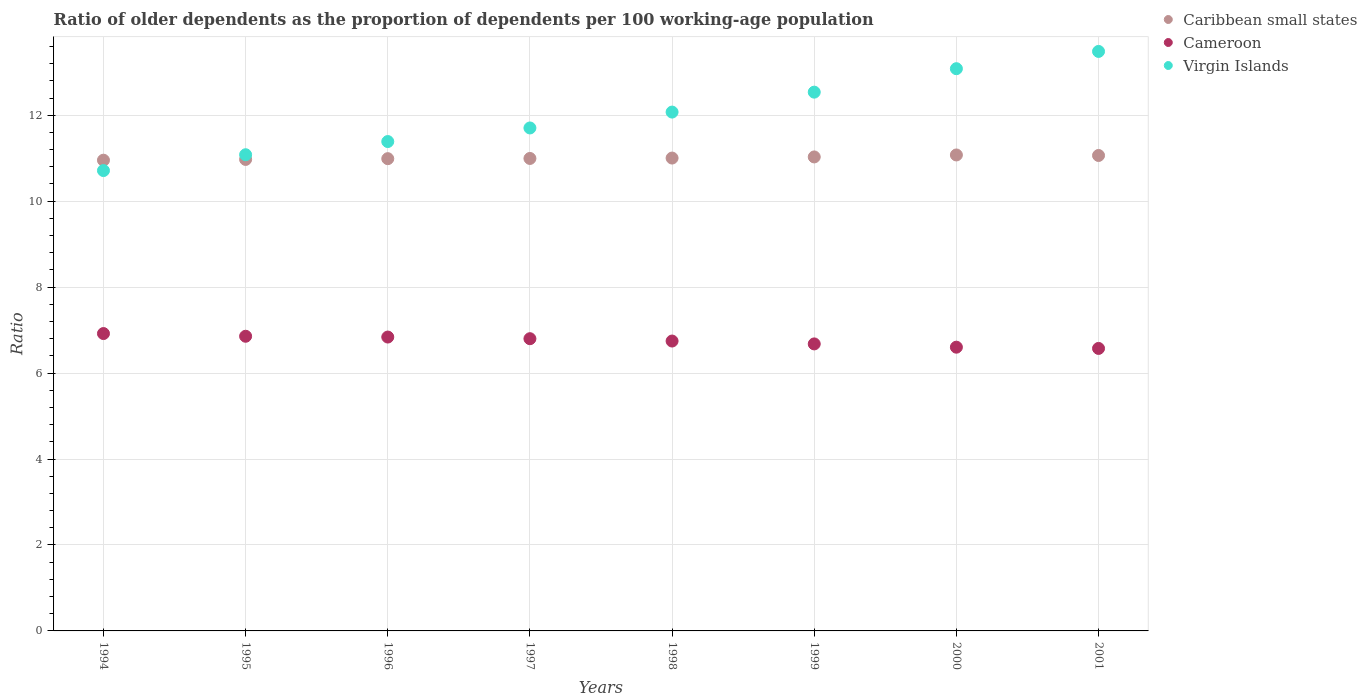What is the age dependency ratio(old) in Virgin Islands in 1995?
Your response must be concise. 11.08. Across all years, what is the maximum age dependency ratio(old) in Cameroon?
Offer a very short reply. 6.92. Across all years, what is the minimum age dependency ratio(old) in Cameroon?
Your response must be concise. 6.57. In which year was the age dependency ratio(old) in Virgin Islands minimum?
Provide a succinct answer. 1994. What is the total age dependency ratio(old) in Caribbean small states in the graph?
Your response must be concise. 88.08. What is the difference between the age dependency ratio(old) in Virgin Islands in 1997 and that in 1998?
Provide a succinct answer. -0.37. What is the difference between the age dependency ratio(old) in Caribbean small states in 1995 and the age dependency ratio(old) in Virgin Islands in 1996?
Give a very brief answer. -0.42. What is the average age dependency ratio(old) in Caribbean small states per year?
Make the answer very short. 11.01. In the year 2001, what is the difference between the age dependency ratio(old) in Caribbean small states and age dependency ratio(old) in Virgin Islands?
Your answer should be compact. -2.42. In how many years, is the age dependency ratio(old) in Virgin Islands greater than 1.6?
Provide a succinct answer. 8. What is the ratio of the age dependency ratio(old) in Cameroon in 1997 to that in 1998?
Your answer should be very brief. 1.01. Is the age dependency ratio(old) in Virgin Islands in 1995 less than that in 2001?
Keep it short and to the point. Yes. Is the difference between the age dependency ratio(old) in Caribbean small states in 1995 and 1998 greater than the difference between the age dependency ratio(old) in Virgin Islands in 1995 and 1998?
Your answer should be compact. Yes. What is the difference between the highest and the second highest age dependency ratio(old) in Virgin Islands?
Your answer should be very brief. 0.4. What is the difference between the highest and the lowest age dependency ratio(old) in Caribbean small states?
Give a very brief answer. 0.12. In how many years, is the age dependency ratio(old) in Caribbean small states greater than the average age dependency ratio(old) in Caribbean small states taken over all years?
Your response must be concise. 3. Is it the case that in every year, the sum of the age dependency ratio(old) in Caribbean small states and age dependency ratio(old) in Virgin Islands  is greater than the age dependency ratio(old) in Cameroon?
Your answer should be very brief. Yes. Is the age dependency ratio(old) in Virgin Islands strictly less than the age dependency ratio(old) in Caribbean small states over the years?
Your response must be concise. No. Are the values on the major ticks of Y-axis written in scientific E-notation?
Your answer should be compact. No. Does the graph contain any zero values?
Ensure brevity in your answer.  No. Does the graph contain grids?
Give a very brief answer. Yes. How are the legend labels stacked?
Give a very brief answer. Vertical. What is the title of the graph?
Provide a short and direct response. Ratio of older dependents as the proportion of dependents per 100 working-age population. What is the label or title of the X-axis?
Offer a very short reply. Years. What is the label or title of the Y-axis?
Keep it short and to the point. Ratio. What is the Ratio in Caribbean small states in 1994?
Make the answer very short. 10.95. What is the Ratio in Cameroon in 1994?
Your response must be concise. 6.92. What is the Ratio in Virgin Islands in 1994?
Give a very brief answer. 10.71. What is the Ratio of Caribbean small states in 1995?
Offer a terse response. 10.97. What is the Ratio in Cameroon in 1995?
Ensure brevity in your answer.  6.86. What is the Ratio of Virgin Islands in 1995?
Your response must be concise. 11.08. What is the Ratio in Caribbean small states in 1996?
Provide a succinct answer. 10.99. What is the Ratio in Cameroon in 1996?
Provide a succinct answer. 6.84. What is the Ratio of Virgin Islands in 1996?
Offer a terse response. 11.39. What is the Ratio of Caribbean small states in 1997?
Keep it short and to the point. 10.99. What is the Ratio in Cameroon in 1997?
Your answer should be very brief. 6.8. What is the Ratio in Virgin Islands in 1997?
Your answer should be compact. 11.7. What is the Ratio of Caribbean small states in 1998?
Provide a short and direct response. 11. What is the Ratio of Cameroon in 1998?
Your response must be concise. 6.75. What is the Ratio in Virgin Islands in 1998?
Your answer should be compact. 12.07. What is the Ratio of Caribbean small states in 1999?
Ensure brevity in your answer.  11.03. What is the Ratio in Cameroon in 1999?
Make the answer very short. 6.68. What is the Ratio of Virgin Islands in 1999?
Provide a succinct answer. 12.54. What is the Ratio in Caribbean small states in 2000?
Give a very brief answer. 11.08. What is the Ratio in Cameroon in 2000?
Offer a terse response. 6.6. What is the Ratio of Virgin Islands in 2000?
Your response must be concise. 13.08. What is the Ratio of Caribbean small states in 2001?
Offer a very short reply. 11.06. What is the Ratio in Cameroon in 2001?
Keep it short and to the point. 6.57. What is the Ratio of Virgin Islands in 2001?
Keep it short and to the point. 13.48. Across all years, what is the maximum Ratio of Caribbean small states?
Your response must be concise. 11.08. Across all years, what is the maximum Ratio in Cameroon?
Offer a terse response. 6.92. Across all years, what is the maximum Ratio of Virgin Islands?
Provide a succinct answer. 13.48. Across all years, what is the minimum Ratio of Caribbean small states?
Keep it short and to the point. 10.95. Across all years, what is the minimum Ratio in Cameroon?
Provide a succinct answer. 6.57. Across all years, what is the minimum Ratio in Virgin Islands?
Your answer should be compact. 10.71. What is the total Ratio of Caribbean small states in the graph?
Offer a very short reply. 88.08. What is the total Ratio in Cameroon in the graph?
Make the answer very short. 54.01. What is the total Ratio of Virgin Islands in the graph?
Keep it short and to the point. 96.06. What is the difference between the Ratio in Caribbean small states in 1994 and that in 1995?
Provide a short and direct response. -0.02. What is the difference between the Ratio in Cameroon in 1994 and that in 1995?
Provide a succinct answer. 0.06. What is the difference between the Ratio of Virgin Islands in 1994 and that in 1995?
Ensure brevity in your answer.  -0.37. What is the difference between the Ratio of Caribbean small states in 1994 and that in 1996?
Offer a very short reply. -0.04. What is the difference between the Ratio of Cameroon in 1994 and that in 1996?
Make the answer very short. 0.08. What is the difference between the Ratio in Virgin Islands in 1994 and that in 1996?
Your response must be concise. -0.68. What is the difference between the Ratio of Caribbean small states in 1994 and that in 1997?
Provide a short and direct response. -0.04. What is the difference between the Ratio in Cameroon in 1994 and that in 1997?
Offer a terse response. 0.12. What is the difference between the Ratio of Virgin Islands in 1994 and that in 1997?
Your response must be concise. -0.99. What is the difference between the Ratio of Caribbean small states in 1994 and that in 1998?
Your answer should be very brief. -0.05. What is the difference between the Ratio in Cameroon in 1994 and that in 1998?
Provide a short and direct response. 0.17. What is the difference between the Ratio in Virgin Islands in 1994 and that in 1998?
Provide a succinct answer. -1.36. What is the difference between the Ratio in Caribbean small states in 1994 and that in 1999?
Provide a succinct answer. -0.08. What is the difference between the Ratio in Cameroon in 1994 and that in 1999?
Keep it short and to the point. 0.24. What is the difference between the Ratio of Virgin Islands in 1994 and that in 1999?
Ensure brevity in your answer.  -1.82. What is the difference between the Ratio in Caribbean small states in 1994 and that in 2000?
Keep it short and to the point. -0.12. What is the difference between the Ratio in Cameroon in 1994 and that in 2000?
Your answer should be very brief. 0.32. What is the difference between the Ratio of Virgin Islands in 1994 and that in 2000?
Your answer should be very brief. -2.37. What is the difference between the Ratio of Caribbean small states in 1994 and that in 2001?
Offer a terse response. -0.11. What is the difference between the Ratio of Cameroon in 1994 and that in 2001?
Keep it short and to the point. 0.35. What is the difference between the Ratio of Virgin Islands in 1994 and that in 2001?
Ensure brevity in your answer.  -2.77. What is the difference between the Ratio of Caribbean small states in 1995 and that in 1996?
Provide a short and direct response. -0.02. What is the difference between the Ratio of Cameroon in 1995 and that in 1996?
Your response must be concise. 0.02. What is the difference between the Ratio of Virgin Islands in 1995 and that in 1996?
Your response must be concise. -0.31. What is the difference between the Ratio in Caribbean small states in 1995 and that in 1997?
Your response must be concise. -0.02. What is the difference between the Ratio of Cameroon in 1995 and that in 1997?
Your answer should be very brief. 0.06. What is the difference between the Ratio of Virgin Islands in 1995 and that in 1997?
Offer a terse response. -0.62. What is the difference between the Ratio in Caribbean small states in 1995 and that in 1998?
Make the answer very short. -0.03. What is the difference between the Ratio of Cameroon in 1995 and that in 1998?
Keep it short and to the point. 0.11. What is the difference between the Ratio of Virgin Islands in 1995 and that in 1998?
Your answer should be compact. -0.99. What is the difference between the Ratio in Caribbean small states in 1995 and that in 1999?
Your response must be concise. -0.06. What is the difference between the Ratio in Cameroon in 1995 and that in 1999?
Keep it short and to the point. 0.18. What is the difference between the Ratio of Virgin Islands in 1995 and that in 1999?
Ensure brevity in your answer.  -1.46. What is the difference between the Ratio of Caribbean small states in 1995 and that in 2000?
Provide a succinct answer. -0.1. What is the difference between the Ratio in Cameroon in 1995 and that in 2000?
Provide a succinct answer. 0.25. What is the difference between the Ratio of Virgin Islands in 1995 and that in 2000?
Offer a terse response. -2. What is the difference between the Ratio of Caribbean small states in 1995 and that in 2001?
Ensure brevity in your answer.  -0.09. What is the difference between the Ratio in Cameroon in 1995 and that in 2001?
Offer a terse response. 0.28. What is the difference between the Ratio in Virgin Islands in 1995 and that in 2001?
Offer a very short reply. -2.4. What is the difference between the Ratio in Caribbean small states in 1996 and that in 1997?
Make the answer very short. -0. What is the difference between the Ratio of Cameroon in 1996 and that in 1997?
Offer a terse response. 0.04. What is the difference between the Ratio in Virgin Islands in 1996 and that in 1997?
Provide a succinct answer. -0.32. What is the difference between the Ratio in Caribbean small states in 1996 and that in 1998?
Provide a succinct answer. -0.01. What is the difference between the Ratio in Cameroon in 1996 and that in 1998?
Your answer should be compact. 0.09. What is the difference between the Ratio of Virgin Islands in 1996 and that in 1998?
Provide a succinct answer. -0.69. What is the difference between the Ratio in Caribbean small states in 1996 and that in 1999?
Make the answer very short. -0.04. What is the difference between the Ratio of Cameroon in 1996 and that in 1999?
Your answer should be compact. 0.16. What is the difference between the Ratio of Virgin Islands in 1996 and that in 1999?
Give a very brief answer. -1.15. What is the difference between the Ratio of Caribbean small states in 1996 and that in 2000?
Make the answer very short. -0.09. What is the difference between the Ratio of Cameroon in 1996 and that in 2000?
Make the answer very short. 0.24. What is the difference between the Ratio of Virgin Islands in 1996 and that in 2000?
Offer a very short reply. -1.7. What is the difference between the Ratio of Caribbean small states in 1996 and that in 2001?
Your answer should be compact. -0.07. What is the difference between the Ratio in Cameroon in 1996 and that in 2001?
Your answer should be compact. 0.26. What is the difference between the Ratio of Virgin Islands in 1996 and that in 2001?
Give a very brief answer. -2.1. What is the difference between the Ratio in Caribbean small states in 1997 and that in 1998?
Offer a terse response. -0.01. What is the difference between the Ratio in Cameroon in 1997 and that in 1998?
Your answer should be compact. 0.05. What is the difference between the Ratio in Virgin Islands in 1997 and that in 1998?
Your response must be concise. -0.37. What is the difference between the Ratio in Caribbean small states in 1997 and that in 1999?
Provide a succinct answer. -0.04. What is the difference between the Ratio in Cameroon in 1997 and that in 1999?
Offer a terse response. 0.12. What is the difference between the Ratio of Virgin Islands in 1997 and that in 1999?
Keep it short and to the point. -0.83. What is the difference between the Ratio of Caribbean small states in 1997 and that in 2000?
Keep it short and to the point. -0.08. What is the difference between the Ratio of Cameroon in 1997 and that in 2000?
Your answer should be compact. 0.2. What is the difference between the Ratio in Virgin Islands in 1997 and that in 2000?
Make the answer very short. -1.38. What is the difference between the Ratio in Caribbean small states in 1997 and that in 2001?
Ensure brevity in your answer.  -0.07. What is the difference between the Ratio in Cameroon in 1997 and that in 2001?
Your answer should be compact. 0.23. What is the difference between the Ratio in Virgin Islands in 1997 and that in 2001?
Provide a short and direct response. -1.78. What is the difference between the Ratio in Caribbean small states in 1998 and that in 1999?
Ensure brevity in your answer.  -0.03. What is the difference between the Ratio in Cameroon in 1998 and that in 1999?
Make the answer very short. 0.07. What is the difference between the Ratio of Virgin Islands in 1998 and that in 1999?
Offer a very short reply. -0.46. What is the difference between the Ratio of Caribbean small states in 1998 and that in 2000?
Provide a succinct answer. -0.07. What is the difference between the Ratio of Cameroon in 1998 and that in 2000?
Ensure brevity in your answer.  0.14. What is the difference between the Ratio of Virgin Islands in 1998 and that in 2000?
Provide a succinct answer. -1.01. What is the difference between the Ratio of Caribbean small states in 1998 and that in 2001?
Offer a terse response. -0.06. What is the difference between the Ratio in Cameroon in 1998 and that in 2001?
Give a very brief answer. 0.17. What is the difference between the Ratio of Virgin Islands in 1998 and that in 2001?
Provide a short and direct response. -1.41. What is the difference between the Ratio in Caribbean small states in 1999 and that in 2000?
Your answer should be very brief. -0.05. What is the difference between the Ratio of Cameroon in 1999 and that in 2000?
Give a very brief answer. 0.08. What is the difference between the Ratio in Virgin Islands in 1999 and that in 2000?
Your answer should be very brief. -0.55. What is the difference between the Ratio in Caribbean small states in 1999 and that in 2001?
Your answer should be compact. -0.03. What is the difference between the Ratio in Cameroon in 1999 and that in 2001?
Offer a terse response. 0.11. What is the difference between the Ratio in Virgin Islands in 1999 and that in 2001?
Your answer should be very brief. -0.95. What is the difference between the Ratio of Caribbean small states in 2000 and that in 2001?
Provide a short and direct response. 0.01. What is the difference between the Ratio of Cameroon in 2000 and that in 2001?
Offer a terse response. 0.03. What is the difference between the Ratio in Virgin Islands in 2000 and that in 2001?
Your answer should be compact. -0.4. What is the difference between the Ratio of Caribbean small states in 1994 and the Ratio of Cameroon in 1995?
Offer a terse response. 4.1. What is the difference between the Ratio of Caribbean small states in 1994 and the Ratio of Virgin Islands in 1995?
Your answer should be very brief. -0.13. What is the difference between the Ratio of Cameroon in 1994 and the Ratio of Virgin Islands in 1995?
Your response must be concise. -4.16. What is the difference between the Ratio in Caribbean small states in 1994 and the Ratio in Cameroon in 1996?
Your response must be concise. 4.12. What is the difference between the Ratio of Caribbean small states in 1994 and the Ratio of Virgin Islands in 1996?
Provide a short and direct response. -0.43. What is the difference between the Ratio of Cameroon in 1994 and the Ratio of Virgin Islands in 1996?
Your answer should be compact. -4.47. What is the difference between the Ratio of Caribbean small states in 1994 and the Ratio of Cameroon in 1997?
Provide a succinct answer. 4.15. What is the difference between the Ratio in Caribbean small states in 1994 and the Ratio in Virgin Islands in 1997?
Your answer should be compact. -0.75. What is the difference between the Ratio of Cameroon in 1994 and the Ratio of Virgin Islands in 1997?
Make the answer very short. -4.78. What is the difference between the Ratio in Caribbean small states in 1994 and the Ratio in Cameroon in 1998?
Offer a terse response. 4.21. What is the difference between the Ratio of Caribbean small states in 1994 and the Ratio of Virgin Islands in 1998?
Offer a very short reply. -1.12. What is the difference between the Ratio in Cameroon in 1994 and the Ratio in Virgin Islands in 1998?
Make the answer very short. -5.15. What is the difference between the Ratio in Caribbean small states in 1994 and the Ratio in Cameroon in 1999?
Your answer should be very brief. 4.28. What is the difference between the Ratio of Caribbean small states in 1994 and the Ratio of Virgin Islands in 1999?
Your response must be concise. -1.58. What is the difference between the Ratio in Cameroon in 1994 and the Ratio in Virgin Islands in 1999?
Provide a short and direct response. -5.62. What is the difference between the Ratio in Caribbean small states in 1994 and the Ratio in Cameroon in 2000?
Make the answer very short. 4.35. What is the difference between the Ratio of Caribbean small states in 1994 and the Ratio of Virgin Islands in 2000?
Offer a very short reply. -2.13. What is the difference between the Ratio of Cameroon in 1994 and the Ratio of Virgin Islands in 2000?
Provide a succinct answer. -6.16. What is the difference between the Ratio in Caribbean small states in 1994 and the Ratio in Cameroon in 2001?
Your answer should be compact. 4.38. What is the difference between the Ratio in Caribbean small states in 1994 and the Ratio in Virgin Islands in 2001?
Your answer should be compact. -2.53. What is the difference between the Ratio in Cameroon in 1994 and the Ratio in Virgin Islands in 2001?
Keep it short and to the point. -6.57. What is the difference between the Ratio in Caribbean small states in 1995 and the Ratio in Cameroon in 1996?
Provide a short and direct response. 4.13. What is the difference between the Ratio of Caribbean small states in 1995 and the Ratio of Virgin Islands in 1996?
Your answer should be compact. -0.42. What is the difference between the Ratio in Cameroon in 1995 and the Ratio in Virgin Islands in 1996?
Make the answer very short. -4.53. What is the difference between the Ratio of Caribbean small states in 1995 and the Ratio of Cameroon in 1997?
Your answer should be very brief. 4.17. What is the difference between the Ratio in Caribbean small states in 1995 and the Ratio in Virgin Islands in 1997?
Make the answer very short. -0.73. What is the difference between the Ratio in Cameroon in 1995 and the Ratio in Virgin Islands in 1997?
Make the answer very short. -4.85. What is the difference between the Ratio in Caribbean small states in 1995 and the Ratio in Cameroon in 1998?
Provide a succinct answer. 4.23. What is the difference between the Ratio of Caribbean small states in 1995 and the Ratio of Virgin Islands in 1998?
Provide a succinct answer. -1.1. What is the difference between the Ratio of Cameroon in 1995 and the Ratio of Virgin Islands in 1998?
Provide a succinct answer. -5.22. What is the difference between the Ratio of Caribbean small states in 1995 and the Ratio of Cameroon in 1999?
Provide a short and direct response. 4.29. What is the difference between the Ratio in Caribbean small states in 1995 and the Ratio in Virgin Islands in 1999?
Ensure brevity in your answer.  -1.57. What is the difference between the Ratio of Cameroon in 1995 and the Ratio of Virgin Islands in 1999?
Your answer should be compact. -5.68. What is the difference between the Ratio in Caribbean small states in 1995 and the Ratio in Cameroon in 2000?
Give a very brief answer. 4.37. What is the difference between the Ratio in Caribbean small states in 1995 and the Ratio in Virgin Islands in 2000?
Keep it short and to the point. -2.11. What is the difference between the Ratio of Cameroon in 1995 and the Ratio of Virgin Islands in 2000?
Keep it short and to the point. -6.23. What is the difference between the Ratio of Caribbean small states in 1995 and the Ratio of Cameroon in 2001?
Your answer should be compact. 4.4. What is the difference between the Ratio of Caribbean small states in 1995 and the Ratio of Virgin Islands in 2001?
Make the answer very short. -2.51. What is the difference between the Ratio of Cameroon in 1995 and the Ratio of Virgin Islands in 2001?
Give a very brief answer. -6.63. What is the difference between the Ratio of Caribbean small states in 1996 and the Ratio of Cameroon in 1997?
Make the answer very short. 4.19. What is the difference between the Ratio in Caribbean small states in 1996 and the Ratio in Virgin Islands in 1997?
Offer a terse response. -0.71. What is the difference between the Ratio of Cameroon in 1996 and the Ratio of Virgin Islands in 1997?
Offer a very short reply. -4.87. What is the difference between the Ratio of Caribbean small states in 1996 and the Ratio of Cameroon in 1998?
Your answer should be very brief. 4.24. What is the difference between the Ratio in Caribbean small states in 1996 and the Ratio in Virgin Islands in 1998?
Give a very brief answer. -1.08. What is the difference between the Ratio in Cameroon in 1996 and the Ratio in Virgin Islands in 1998?
Make the answer very short. -5.23. What is the difference between the Ratio of Caribbean small states in 1996 and the Ratio of Cameroon in 1999?
Make the answer very short. 4.31. What is the difference between the Ratio in Caribbean small states in 1996 and the Ratio in Virgin Islands in 1999?
Offer a very short reply. -1.55. What is the difference between the Ratio of Cameroon in 1996 and the Ratio of Virgin Islands in 1999?
Your answer should be compact. -5.7. What is the difference between the Ratio in Caribbean small states in 1996 and the Ratio in Cameroon in 2000?
Provide a short and direct response. 4.39. What is the difference between the Ratio of Caribbean small states in 1996 and the Ratio of Virgin Islands in 2000?
Give a very brief answer. -2.09. What is the difference between the Ratio in Cameroon in 1996 and the Ratio in Virgin Islands in 2000?
Offer a terse response. -6.24. What is the difference between the Ratio of Caribbean small states in 1996 and the Ratio of Cameroon in 2001?
Provide a succinct answer. 4.42. What is the difference between the Ratio in Caribbean small states in 1996 and the Ratio in Virgin Islands in 2001?
Offer a very short reply. -2.5. What is the difference between the Ratio in Cameroon in 1996 and the Ratio in Virgin Islands in 2001?
Your answer should be compact. -6.65. What is the difference between the Ratio in Caribbean small states in 1997 and the Ratio in Cameroon in 1998?
Provide a short and direct response. 4.25. What is the difference between the Ratio in Caribbean small states in 1997 and the Ratio in Virgin Islands in 1998?
Keep it short and to the point. -1.08. What is the difference between the Ratio of Cameroon in 1997 and the Ratio of Virgin Islands in 1998?
Make the answer very short. -5.27. What is the difference between the Ratio of Caribbean small states in 1997 and the Ratio of Cameroon in 1999?
Ensure brevity in your answer.  4.32. What is the difference between the Ratio of Caribbean small states in 1997 and the Ratio of Virgin Islands in 1999?
Provide a short and direct response. -1.54. What is the difference between the Ratio of Cameroon in 1997 and the Ratio of Virgin Islands in 1999?
Ensure brevity in your answer.  -5.74. What is the difference between the Ratio of Caribbean small states in 1997 and the Ratio of Cameroon in 2000?
Make the answer very short. 4.39. What is the difference between the Ratio in Caribbean small states in 1997 and the Ratio in Virgin Islands in 2000?
Your answer should be compact. -2.09. What is the difference between the Ratio of Cameroon in 1997 and the Ratio of Virgin Islands in 2000?
Provide a short and direct response. -6.28. What is the difference between the Ratio of Caribbean small states in 1997 and the Ratio of Cameroon in 2001?
Provide a short and direct response. 4.42. What is the difference between the Ratio of Caribbean small states in 1997 and the Ratio of Virgin Islands in 2001?
Make the answer very short. -2.49. What is the difference between the Ratio in Cameroon in 1997 and the Ratio in Virgin Islands in 2001?
Provide a short and direct response. -6.68. What is the difference between the Ratio in Caribbean small states in 1998 and the Ratio in Cameroon in 1999?
Offer a very short reply. 4.32. What is the difference between the Ratio in Caribbean small states in 1998 and the Ratio in Virgin Islands in 1999?
Offer a terse response. -1.53. What is the difference between the Ratio in Cameroon in 1998 and the Ratio in Virgin Islands in 1999?
Give a very brief answer. -5.79. What is the difference between the Ratio of Caribbean small states in 1998 and the Ratio of Cameroon in 2000?
Offer a terse response. 4.4. What is the difference between the Ratio of Caribbean small states in 1998 and the Ratio of Virgin Islands in 2000?
Your answer should be compact. -2.08. What is the difference between the Ratio of Cameroon in 1998 and the Ratio of Virgin Islands in 2000?
Offer a terse response. -6.34. What is the difference between the Ratio in Caribbean small states in 1998 and the Ratio in Cameroon in 2001?
Keep it short and to the point. 4.43. What is the difference between the Ratio in Caribbean small states in 1998 and the Ratio in Virgin Islands in 2001?
Your answer should be compact. -2.48. What is the difference between the Ratio of Cameroon in 1998 and the Ratio of Virgin Islands in 2001?
Offer a very short reply. -6.74. What is the difference between the Ratio in Caribbean small states in 1999 and the Ratio in Cameroon in 2000?
Your response must be concise. 4.43. What is the difference between the Ratio in Caribbean small states in 1999 and the Ratio in Virgin Islands in 2000?
Your answer should be very brief. -2.05. What is the difference between the Ratio in Cameroon in 1999 and the Ratio in Virgin Islands in 2000?
Your answer should be very brief. -6.4. What is the difference between the Ratio in Caribbean small states in 1999 and the Ratio in Cameroon in 2001?
Offer a very short reply. 4.46. What is the difference between the Ratio in Caribbean small states in 1999 and the Ratio in Virgin Islands in 2001?
Provide a succinct answer. -2.46. What is the difference between the Ratio of Cameroon in 1999 and the Ratio of Virgin Islands in 2001?
Provide a short and direct response. -6.81. What is the difference between the Ratio in Caribbean small states in 2000 and the Ratio in Cameroon in 2001?
Provide a succinct answer. 4.5. What is the difference between the Ratio in Caribbean small states in 2000 and the Ratio in Virgin Islands in 2001?
Ensure brevity in your answer.  -2.41. What is the difference between the Ratio in Cameroon in 2000 and the Ratio in Virgin Islands in 2001?
Ensure brevity in your answer.  -6.88. What is the average Ratio of Caribbean small states per year?
Your response must be concise. 11.01. What is the average Ratio of Cameroon per year?
Make the answer very short. 6.75. What is the average Ratio in Virgin Islands per year?
Keep it short and to the point. 12.01. In the year 1994, what is the difference between the Ratio in Caribbean small states and Ratio in Cameroon?
Your answer should be very brief. 4.03. In the year 1994, what is the difference between the Ratio in Caribbean small states and Ratio in Virgin Islands?
Give a very brief answer. 0.24. In the year 1994, what is the difference between the Ratio of Cameroon and Ratio of Virgin Islands?
Offer a terse response. -3.79. In the year 1995, what is the difference between the Ratio of Caribbean small states and Ratio of Cameroon?
Offer a terse response. 4.11. In the year 1995, what is the difference between the Ratio in Caribbean small states and Ratio in Virgin Islands?
Keep it short and to the point. -0.11. In the year 1995, what is the difference between the Ratio of Cameroon and Ratio of Virgin Islands?
Give a very brief answer. -4.22. In the year 1996, what is the difference between the Ratio of Caribbean small states and Ratio of Cameroon?
Keep it short and to the point. 4.15. In the year 1996, what is the difference between the Ratio of Caribbean small states and Ratio of Virgin Islands?
Offer a very short reply. -0.4. In the year 1996, what is the difference between the Ratio of Cameroon and Ratio of Virgin Islands?
Give a very brief answer. -4.55. In the year 1997, what is the difference between the Ratio of Caribbean small states and Ratio of Cameroon?
Give a very brief answer. 4.19. In the year 1997, what is the difference between the Ratio of Caribbean small states and Ratio of Virgin Islands?
Ensure brevity in your answer.  -0.71. In the year 1997, what is the difference between the Ratio of Cameroon and Ratio of Virgin Islands?
Ensure brevity in your answer.  -4.9. In the year 1998, what is the difference between the Ratio in Caribbean small states and Ratio in Cameroon?
Offer a very short reply. 4.26. In the year 1998, what is the difference between the Ratio of Caribbean small states and Ratio of Virgin Islands?
Your answer should be compact. -1.07. In the year 1998, what is the difference between the Ratio of Cameroon and Ratio of Virgin Islands?
Your answer should be compact. -5.33. In the year 1999, what is the difference between the Ratio in Caribbean small states and Ratio in Cameroon?
Provide a succinct answer. 4.35. In the year 1999, what is the difference between the Ratio of Caribbean small states and Ratio of Virgin Islands?
Offer a very short reply. -1.51. In the year 1999, what is the difference between the Ratio of Cameroon and Ratio of Virgin Islands?
Offer a terse response. -5.86. In the year 2000, what is the difference between the Ratio in Caribbean small states and Ratio in Cameroon?
Offer a terse response. 4.47. In the year 2000, what is the difference between the Ratio of Caribbean small states and Ratio of Virgin Islands?
Your response must be concise. -2.01. In the year 2000, what is the difference between the Ratio in Cameroon and Ratio in Virgin Islands?
Ensure brevity in your answer.  -6.48. In the year 2001, what is the difference between the Ratio in Caribbean small states and Ratio in Cameroon?
Offer a very short reply. 4.49. In the year 2001, what is the difference between the Ratio in Caribbean small states and Ratio in Virgin Islands?
Keep it short and to the point. -2.42. In the year 2001, what is the difference between the Ratio of Cameroon and Ratio of Virgin Islands?
Give a very brief answer. -6.91. What is the ratio of the Ratio of Caribbean small states in 1994 to that in 1995?
Your answer should be very brief. 1. What is the ratio of the Ratio in Cameroon in 1994 to that in 1995?
Give a very brief answer. 1.01. What is the ratio of the Ratio of Virgin Islands in 1994 to that in 1995?
Make the answer very short. 0.97. What is the ratio of the Ratio in Cameroon in 1994 to that in 1996?
Ensure brevity in your answer.  1.01. What is the ratio of the Ratio in Virgin Islands in 1994 to that in 1996?
Your response must be concise. 0.94. What is the ratio of the Ratio in Cameroon in 1994 to that in 1997?
Your answer should be compact. 1.02. What is the ratio of the Ratio of Virgin Islands in 1994 to that in 1997?
Give a very brief answer. 0.92. What is the ratio of the Ratio of Cameroon in 1994 to that in 1998?
Your response must be concise. 1.03. What is the ratio of the Ratio of Virgin Islands in 1994 to that in 1998?
Keep it short and to the point. 0.89. What is the ratio of the Ratio of Caribbean small states in 1994 to that in 1999?
Your response must be concise. 0.99. What is the ratio of the Ratio of Cameroon in 1994 to that in 1999?
Ensure brevity in your answer.  1.04. What is the ratio of the Ratio in Virgin Islands in 1994 to that in 1999?
Offer a very short reply. 0.85. What is the ratio of the Ratio in Caribbean small states in 1994 to that in 2000?
Give a very brief answer. 0.99. What is the ratio of the Ratio of Cameroon in 1994 to that in 2000?
Provide a succinct answer. 1.05. What is the ratio of the Ratio of Virgin Islands in 1994 to that in 2000?
Ensure brevity in your answer.  0.82. What is the ratio of the Ratio of Caribbean small states in 1994 to that in 2001?
Your answer should be very brief. 0.99. What is the ratio of the Ratio of Cameroon in 1994 to that in 2001?
Offer a terse response. 1.05. What is the ratio of the Ratio of Virgin Islands in 1994 to that in 2001?
Give a very brief answer. 0.79. What is the ratio of the Ratio in Caribbean small states in 1995 to that in 1996?
Give a very brief answer. 1. What is the ratio of the Ratio of Cameroon in 1995 to that in 1996?
Make the answer very short. 1. What is the ratio of the Ratio in Virgin Islands in 1995 to that in 1996?
Give a very brief answer. 0.97. What is the ratio of the Ratio in Caribbean small states in 1995 to that in 1997?
Offer a very short reply. 1. What is the ratio of the Ratio of Cameroon in 1995 to that in 1997?
Give a very brief answer. 1.01. What is the ratio of the Ratio in Virgin Islands in 1995 to that in 1997?
Give a very brief answer. 0.95. What is the ratio of the Ratio of Caribbean small states in 1995 to that in 1998?
Provide a short and direct response. 1. What is the ratio of the Ratio of Cameroon in 1995 to that in 1998?
Your answer should be compact. 1.02. What is the ratio of the Ratio of Virgin Islands in 1995 to that in 1998?
Offer a very short reply. 0.92. What is the ratio of the Ratio of Cameroon in 1995 to that in 1999?
Your answer should be very brief. 1.03. What is the ratio of the Ratio in Virgin Islands in 1995 to that in 1999?
Make the answer very short. 0.88. What is the ratio of the Ratio in Caribbean small states in 1995 to that in 2000?
Give a very brief answer. 0.99. What is the ratio of the Ratio in Cameroon in 1995 to that in 2000?
Make the answer very short. 1.04. What is the ratio of the Ratio in Virgin Islands in 1995 to that in 2000?
Provide a succinct answer. 0.85. What is the ratio of the Ratio of Caribbean small states in 1995 to that in 2001?
Offer a very short reply. 0.99. What is the ratio of the Ratio of Cameroon in 1995 to that in 2001?
Your answer should be compact. 1.04. What is the ratio of the Ratio in Virgin Islands in 1995 to that in 2001?
Your answer should be compact. 0.82. What is the ratio of the Ratio in Caribbean small states in 1996 to that in 1997?
Keep it short and to the point. 1. What is the ratio of the Ratio of Cameroon in 1996 to that in 1997?
Your response must be concise. 1.01. What is the ratio of the Ratio of Cameroon in 1996 to that in 1998?
Your answer should be very brief. 1.01. What is the ratio of the Ratio in Virgin Islands in 1996 to that in 1998?
Offer a terse response. 0.94. What is the ratio of the Ratio in Cameroon in 1996 to that in 1999?
Provide a short and direct response. 1.02. What is the ratio of the Ratio of Virgin Islands in 1996 to that in 1999?
Ensure brevity in your answer.  0.91. What is the ratio of the Ratio in Cameroon in 1996 to that in 2000?
Keep it short and to the point. 1.04. What is the ratio of the Ratio in Virgin Islands in 1996 to that in 2000?
Provide a short and direct response. 0.87. What is the ratio of the Ratio of Caribbean small states in 1996 to that in 2001?
Offer a very short reply. 0.99. What is the ratio of the Ratio of Cameroon in 1996 to that in 2001?
Your answer should be very brief. 1.04. What is the ratio of the Ratio in Virgin Islands in 1996 to that in 2001?
Give a very brief answer. 0.84. What is the ratio of the Ratio of Caribbean small states in 1997 to that in 1998?
Ensure brevity in your answer.  1. What is the ratio of the Ratio of Virgin Islands in 1997 to that in 1998?
Your answer should be very brief. 0.97. What is the ratio of the Ratio in Caribbean small states in 1997 to that in 1999?
Provide a short and direct response. 1. What is the ratio of the Ratio in Cameroon in 1997 to that in 1999?
Ensure brevity in your answer.  1.02. What is the ratio of the Ratio in Virgin Islands in 1997 to that in 1999?
Your response must be concise. 0.93. What is the ratio of the Ratio in Caribbean small states in 1997 to that in 2000?
Provide a short and direct response. 0.99. What is the ratio of the Ratio in Cameroon in 1997 to that in 2000?
Provide a succinct answer. 1.03. What is the ratio of the Ratio of Virgin Islands in 1997 to that in 2000?
Your answer should be compact. 0.89. What is the ratio of the Ratio in Caribbean small states in 1997 to that in 2001?
Provide a succinct answer. 0.99. What is the ratio of the Ratio of Cameroon in 1997 to that in 2001?
Offer a terse response. 1.03. What is the ratio of the Ratio in Virgin Islands in 1997 to that in 2001?
Your answer should be compact. 0.87. What is the ratio of the Ratio of Caribbean small states in 1998 to that in 1999?
Keep it short and to the point. 1. What is the ratio of the Ratio in Cameroon in 1998 to that in 1999?
Your response must be concise. 1.01. What is the ratio of the Ratio in Caribbean small states in 1998 to that in 2000?
Provide a short and direct response. 0.99. What is the ratio of the Ratio of Cameroon in 1998 to that in 2000?
Ensure brevity in your answer.  1.02. What is the ratio of the Ratio in Virgin Islands in 1998 to that in 2000?
Keep it short and to the point. 0.92. What is the ratio of the Ratio in Caribbean small states in 1998 to that in 2001?
Offer a terse response. 0.99. What is the ratio of the Ratio of Cameroon in 1998 to that in 2001?
Offer a very short reply. 1.03. What is the ratio of the Ratio in Virgin Islands in 1998 to that in 2001?
Offer a very short reply. 0.9. What is the ratio of the Ratio of Caribbean small states in 1999 to that in 2000?
Offer a very short reply. 1. What is the ratio of the Ratio of Cameroon in 1999 to that in 2000?
Ensure brevity in your answer.  1.01. What is the ratio of the Ratio in Cameroon in 1999 to that in 2001?
Your answer should be very brief. 1.02. What is the ratio of the Ratio of Virgin Islands in 1999 to that in 2001?
Ensure brevity in your answer.  0.93. What is the ratio of the Ratio of Virgin Islands in 2000 to that in 2001?
Provide a succinct answer. 0.97. What is the difference between the highest and the second highest Ratio in Caribbean small states?
Offer a very short reply. 0.01. What is the difference between the highest and the second highest Ratio in Cameroon?
Offer a terse response. 0.06. What is the difference between the highest and the second highest Ratio of Virgin Islands?
Your answer should be compact. 0.4. What is the difference between the highest and the lowest Ratio of Caribbean small states?
Provide a short and direct response. 0.12. What is the difference between the highest and the lowest Ratio of Cameroon?
Make the answer very short. 0.35. What is the difference between the highest and the lowest Ratio of Virgin Islands?
Offer a terse response. 2.77. 